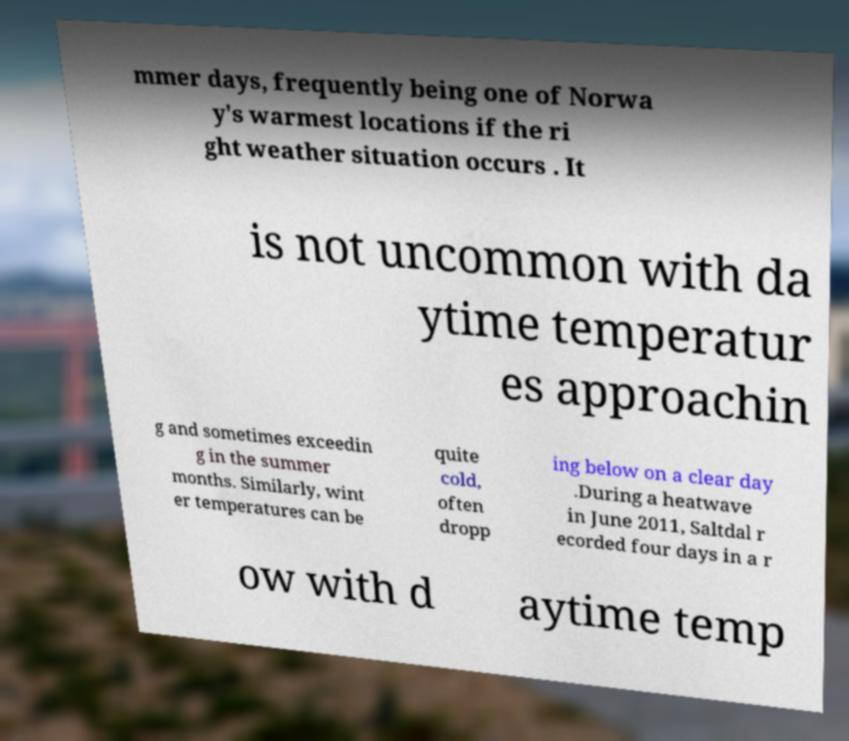What messages or text are displayed in this image? I need them in a readable, typed format. mmer days, frequently being one of Norwa y's warmest locations if the ri ght weather situation occurs . It is not uncommon with da ytime temperatur es approachin g and sometimes exceedin g in the summer months. Similarly, wint er temperatures can be quite cold, often dropp ing below on a clear day .During a heatwave in June 2011, Saltdal r ecorded four days in a r ow with d aytime temp 